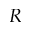Convert formula to latex. <formula><loc_0><loc_0><loc_500><loc_500>R</formula> 